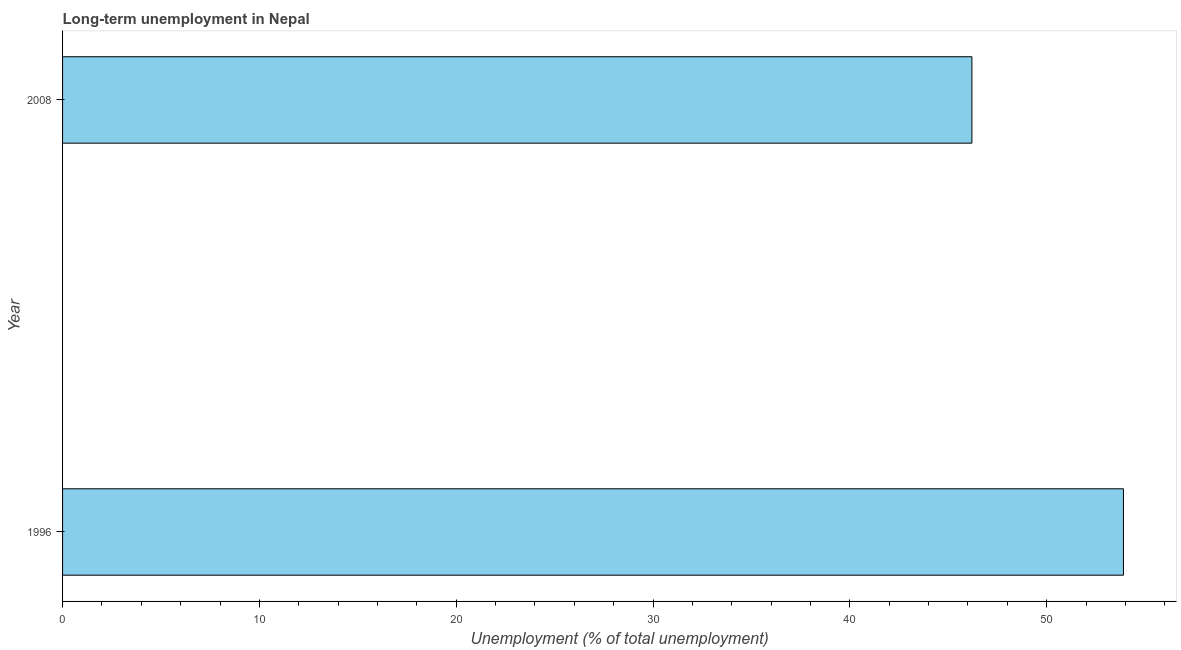Does the graph contain any zero values?
Make the answer very short. No. Does the graph contain grids?
Give a very brief answer. No. What is the title of the graph?
Give a very brief answer. Long-term unemployment in Nepal. What is the label or title of the X-axis?
Offer a terse response. Unemployment (% of total unemployment). What is the long-term unemployment in 1996?
Your answer should be very brief. 53.9. Across all years, what is the maximum long-term unemployment?
Offer a very short reply. 53.9. Across all years, what is the minimum long-term unemployment?
Offer a very short reply. 46.2. In which year was the long-term unemployment minimum?
Provide a succinct answer. 2008. What is the sum of the long-term unemployment?
Provide a short and direct response. 100.1. What is the average long-term unemployment per year?
Give a very brief answer. 50.05. What is the median long-term unemployment?
Your response must be concise. 50.05. Do a majority of the years between 2008 and 1996 (inclusive) have long-term unemployment greater than 50 %?
Your answer should be compact. No. What is the ratio of the long-term unemployment in 1996 to that in 2008?
Offer a terse response. 1.17. Is the long-term unemployment in 1996 less than that in 2008?
Keep it short and to the point. No. How many years are there in the graph?
Ensure brevity in your answer.  2. What is the difference between two consecutive major ticks on the X-axis?
Make the answer very short. 10. What is the Unemployment (% of total unemployment) in 1996?
Provide a short and direct response. 53.9. What is the Unemployment (% of total unemployment) of 2008?
Provide a short and direct response. 46.2. What is the difference between the Unemployment (% of total unemployment) in 1996 and 2008?
Your response must be concise. 7.7. What is the ratio of the Unemployment (% of total unemployment) in 1996 to that in 2008?
Your response must be concise. 1.17. 